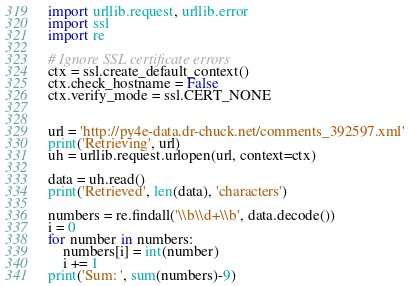<code> <loc_0><loc_0><loc_500><loc_500><_Python_>import urllib.request, urllib.error
import ssl
import re

# Ignore SSL certificate errors
ctx = ssl.create_default_context()
ctx.check_hostname = False
ctx.verify_mode = ssl.CERT_NONE


url = 'http://py4e-data.dr-chuck.net/comments_392597.xml'
print('Retrieving', url)
uh = urllib.request.urlopen(url, context=ctx)

data = uh.read()
print('Retrieved', len(data), 'characters')

numbers = re.findall('\\b\\d+\\b', data.decode())
i = 0
for number in numbers:
    numbers[i] = int(number)
    i += 1
print('Sum: ', sum(numbers)-9)

</code> 